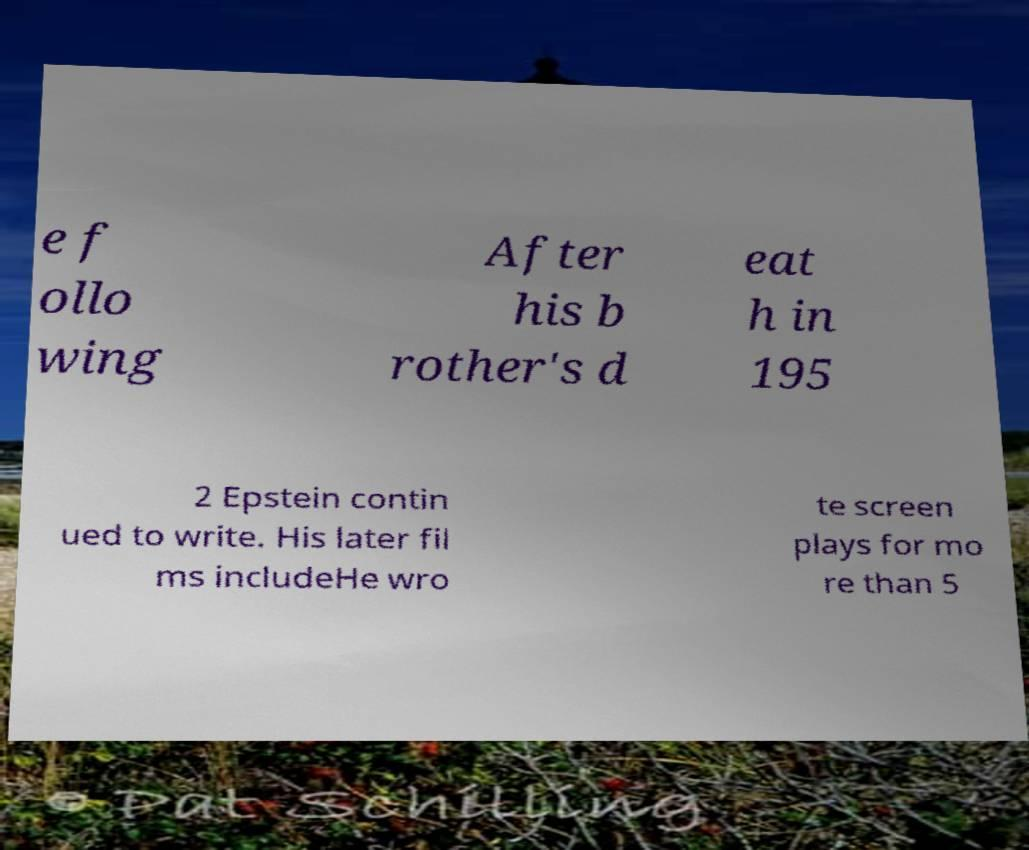There's text embedded in this image that I need extracted. Can you transcribe it verbatim? e f ollo wing After his b rother's d eat h in 195 2 Epstein contin ued to write. His later fil ms includeHe wro te screen plays for mo re than 5 